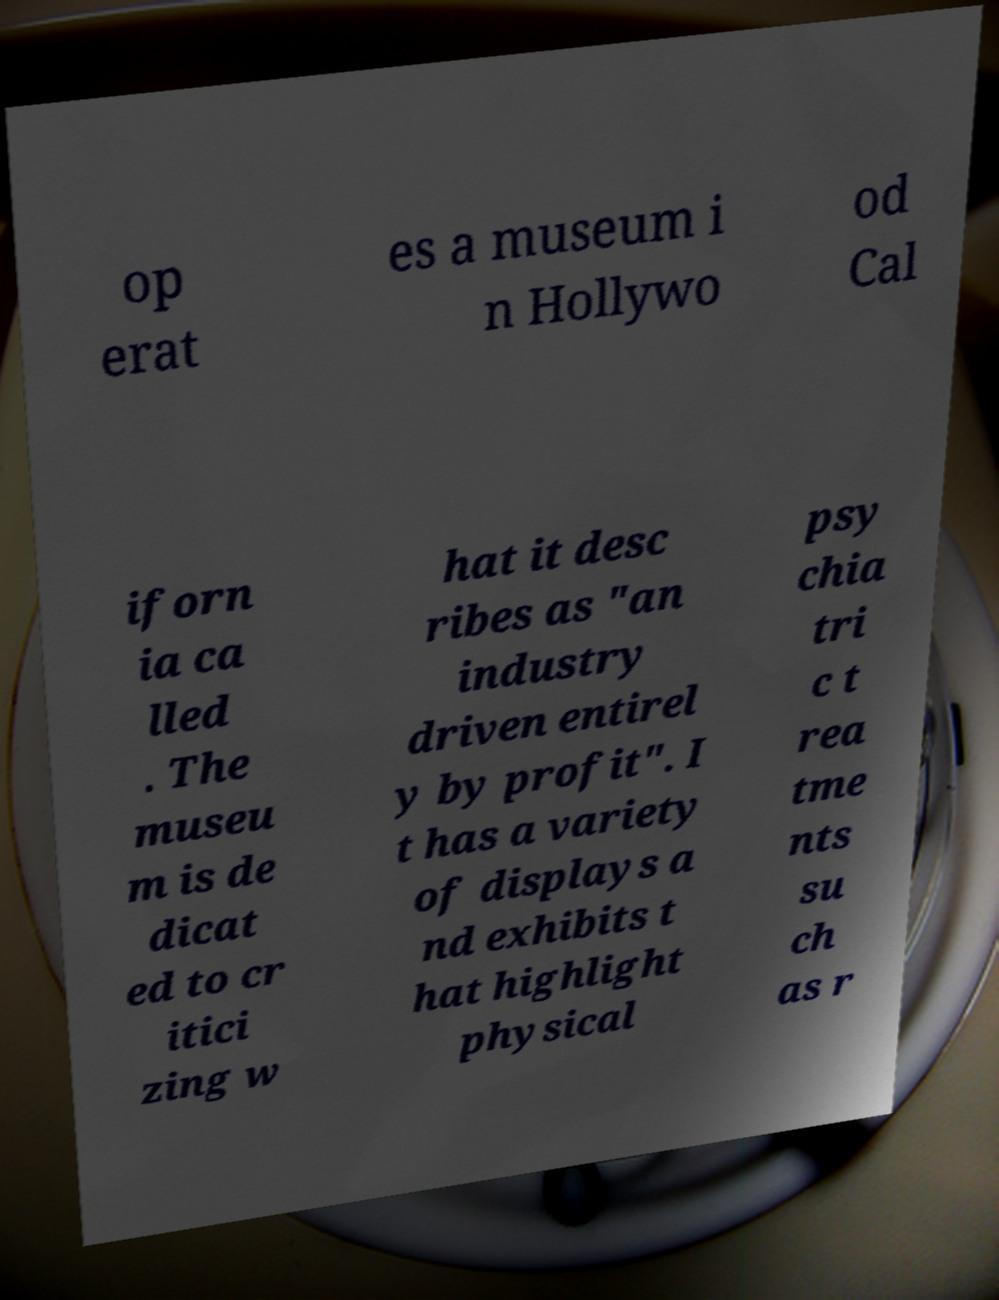Please read and relay the text visible in this image. What does it say? op erat es a museum i n Hollywo od Cal iforn ia ca lled . The museu m is de dicat ed to cr itici zing w hat it desc ribes as "an industry driven entirel y by profit". I t has a variety of displays a nd exhibits t hat highlight physical psy chia tri c t rea tme nts su ch as r 